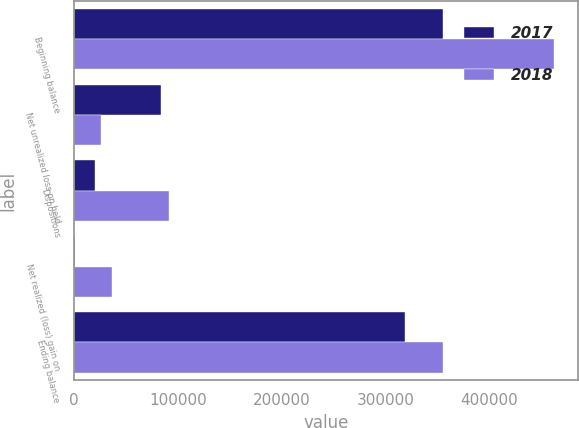Convert chart. <chart><loc_0><loc_0><loc_500><loc_500><stacked_bar_chart><ecel><fcel>Beginning balance<fcel>Net unrealized loss on held<fcel>Dispositions<fcel>Net realized (loss) gain on<fcel>Ending balance<nl><fcel>2017<fcel>354804<fcel>83794<fcel>20290<fcel>912<fcel>318758<nl><fcel>2018<fcel>462132<fcel>25807<fcel>91606<fcel>36078<fcel>354804<nl></chart> 